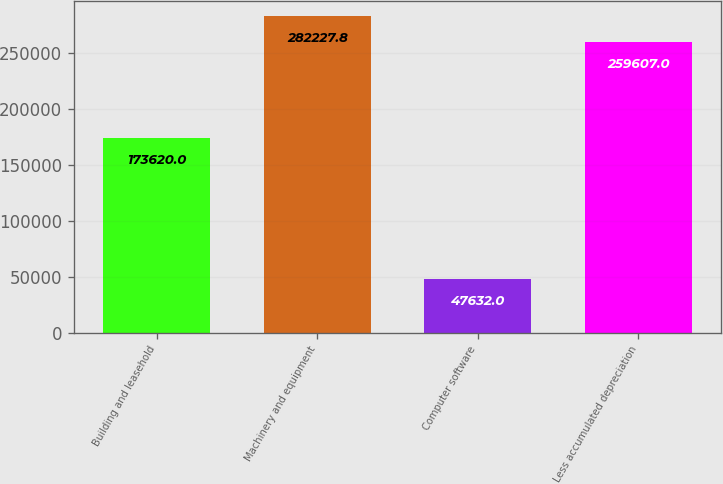<chart> <loc_0><loc_0><loc_500><loc_500><bar_chart><fcel>Building and leasehold<fcel>Machinery and equipment<fcel>Computer software<fcel>Less accumulated depreciation<nl><fcel>173620<fcel>282228<fcel>47632<fcel>259607<nl></chart> 